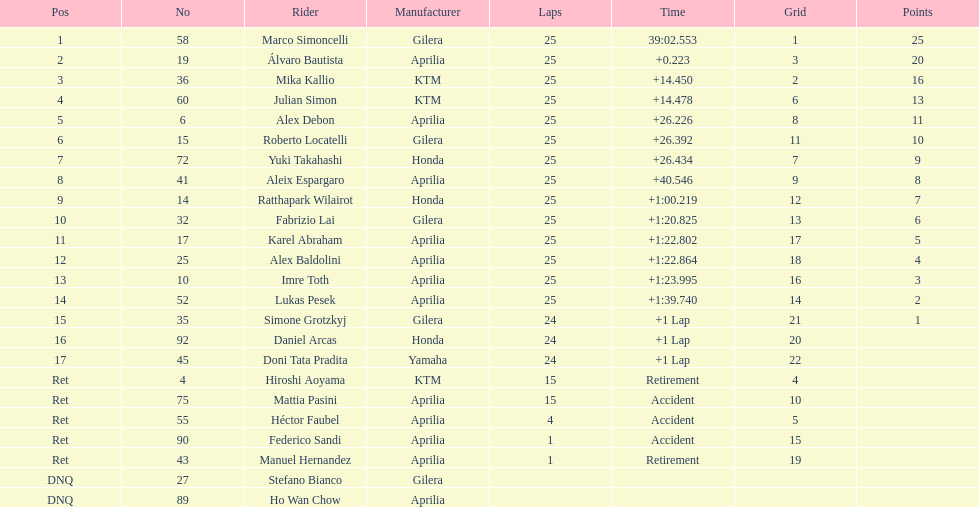The country with the largest population of riders is? Italy. 